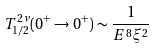Convert formula to latex. <formula><loc_0><loc_0><loc_500><loc_500>T _ { 1 / 2 } ^ { 2 \nu } ( 0 ^ { + } \rightarrow 0 ^ { + } ) \sim \frac { 1 } { E ^ { 8 } \xi ^ { 2 } }</formula> 